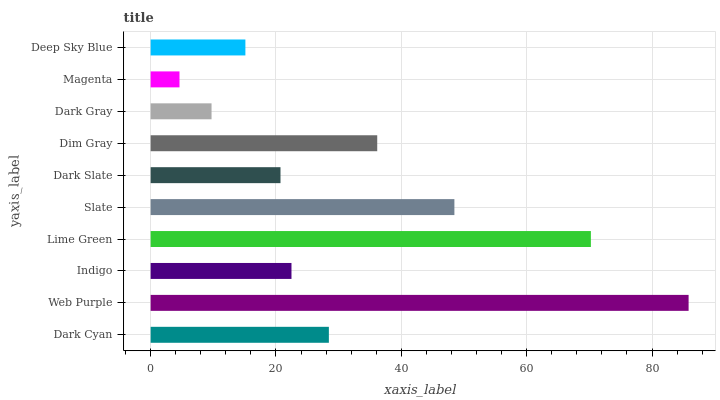Is Magenta the minimum?
Answer yes or no. Yes. Is Web Purple the maximum?
Answer yes or no. Yes. Is Indigo the minimum?
Answer yes or no. No. Is Indigo the maximum?
Answer yes or no. No. Is Web Purple greater than Indigo?
Answer yes or no. Yes. Is Indigo less than Web Purple?
Answer yes or no. Yes. Is Indigo greater than Web Purple?
Answer yes or no. No. Is Web Purple less than Indigo?
Answer yes or no. No. Is Dark Cyan the high median?
Answer yes or no. Yes. Is Indigo the low median?
Answer yes or no. Yes. Is Dim Gray the high median?
Answer yes or no. No. Is Dim Gray the low median?
Answer yes or no. No. 